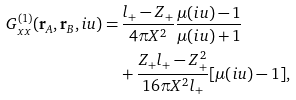<formula> <loc_0><loc_0><loc_500><loc_500>G ^ { ( 1 ) } _ { x x } ( \mathbf r _ { A } , \mathbf r _ { B } , i u ) = & \, \frac { l _ { + } - Z _ { + } } { 4 \pi X ^ { 2 } } \frac { \mu ( i u ) - 1 } { \mu ( i u ) + 1 } \\ & + \frac { Z _ { + } l _ { + } - Z _ { + } ^ { 2 } } { 1 6 \pi X ^ { 2 } l _ { + } } [ \mu ( i u ) - 1 ] ,</formula> 